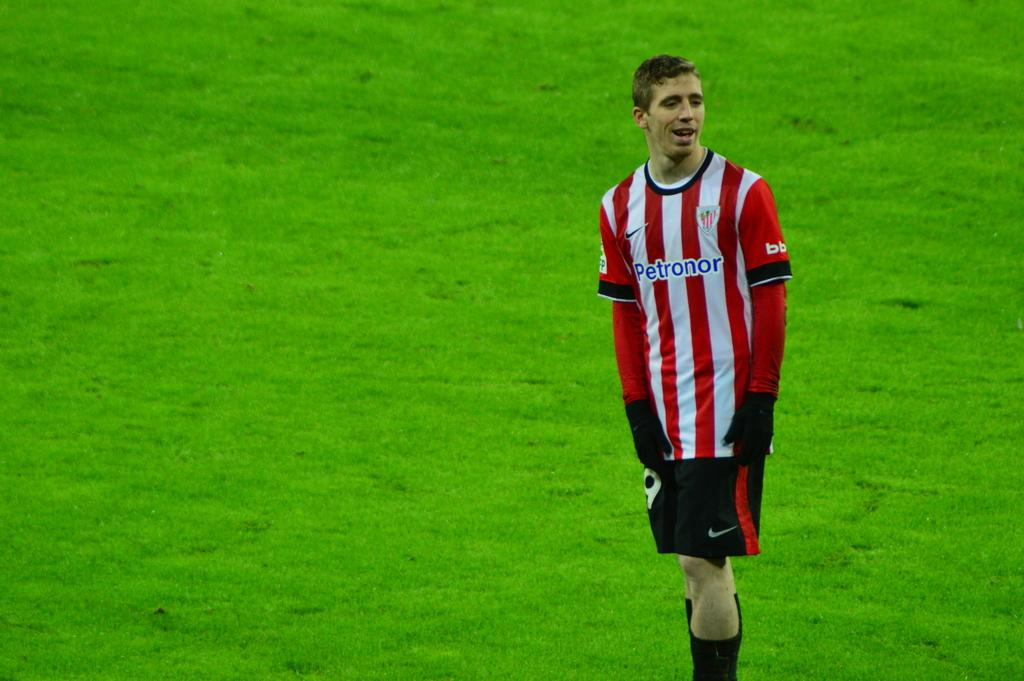<image>
Write a terse but informative summary of the picture. a person wearing a jersey that has the word petronor on it 